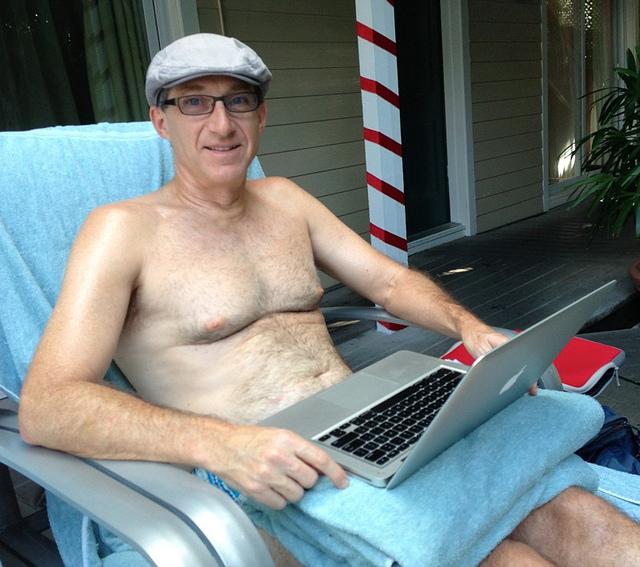What kind of laptop is in the photograph?
Short answer required. Apple. Is the man wearing a shirt?
Short answer required. No. What style of house is pictured behind the man?
Answer briefly. Ranch. 